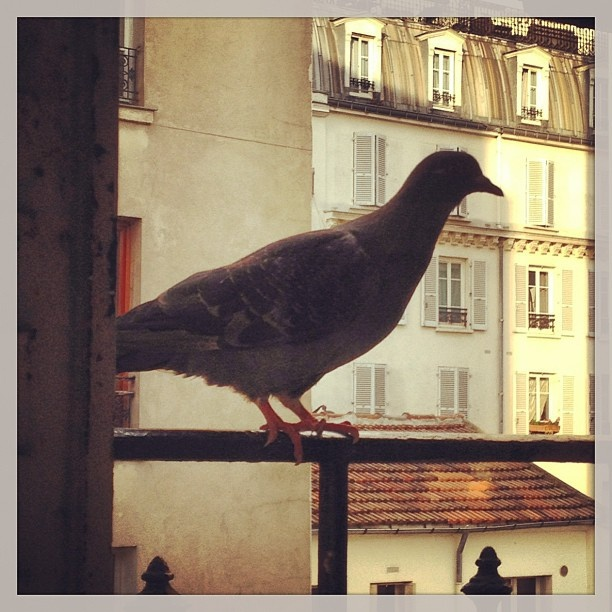Describe the objects in this image and their specific colors. I can see a bird in darkgray, black, and brown tones in this image. 